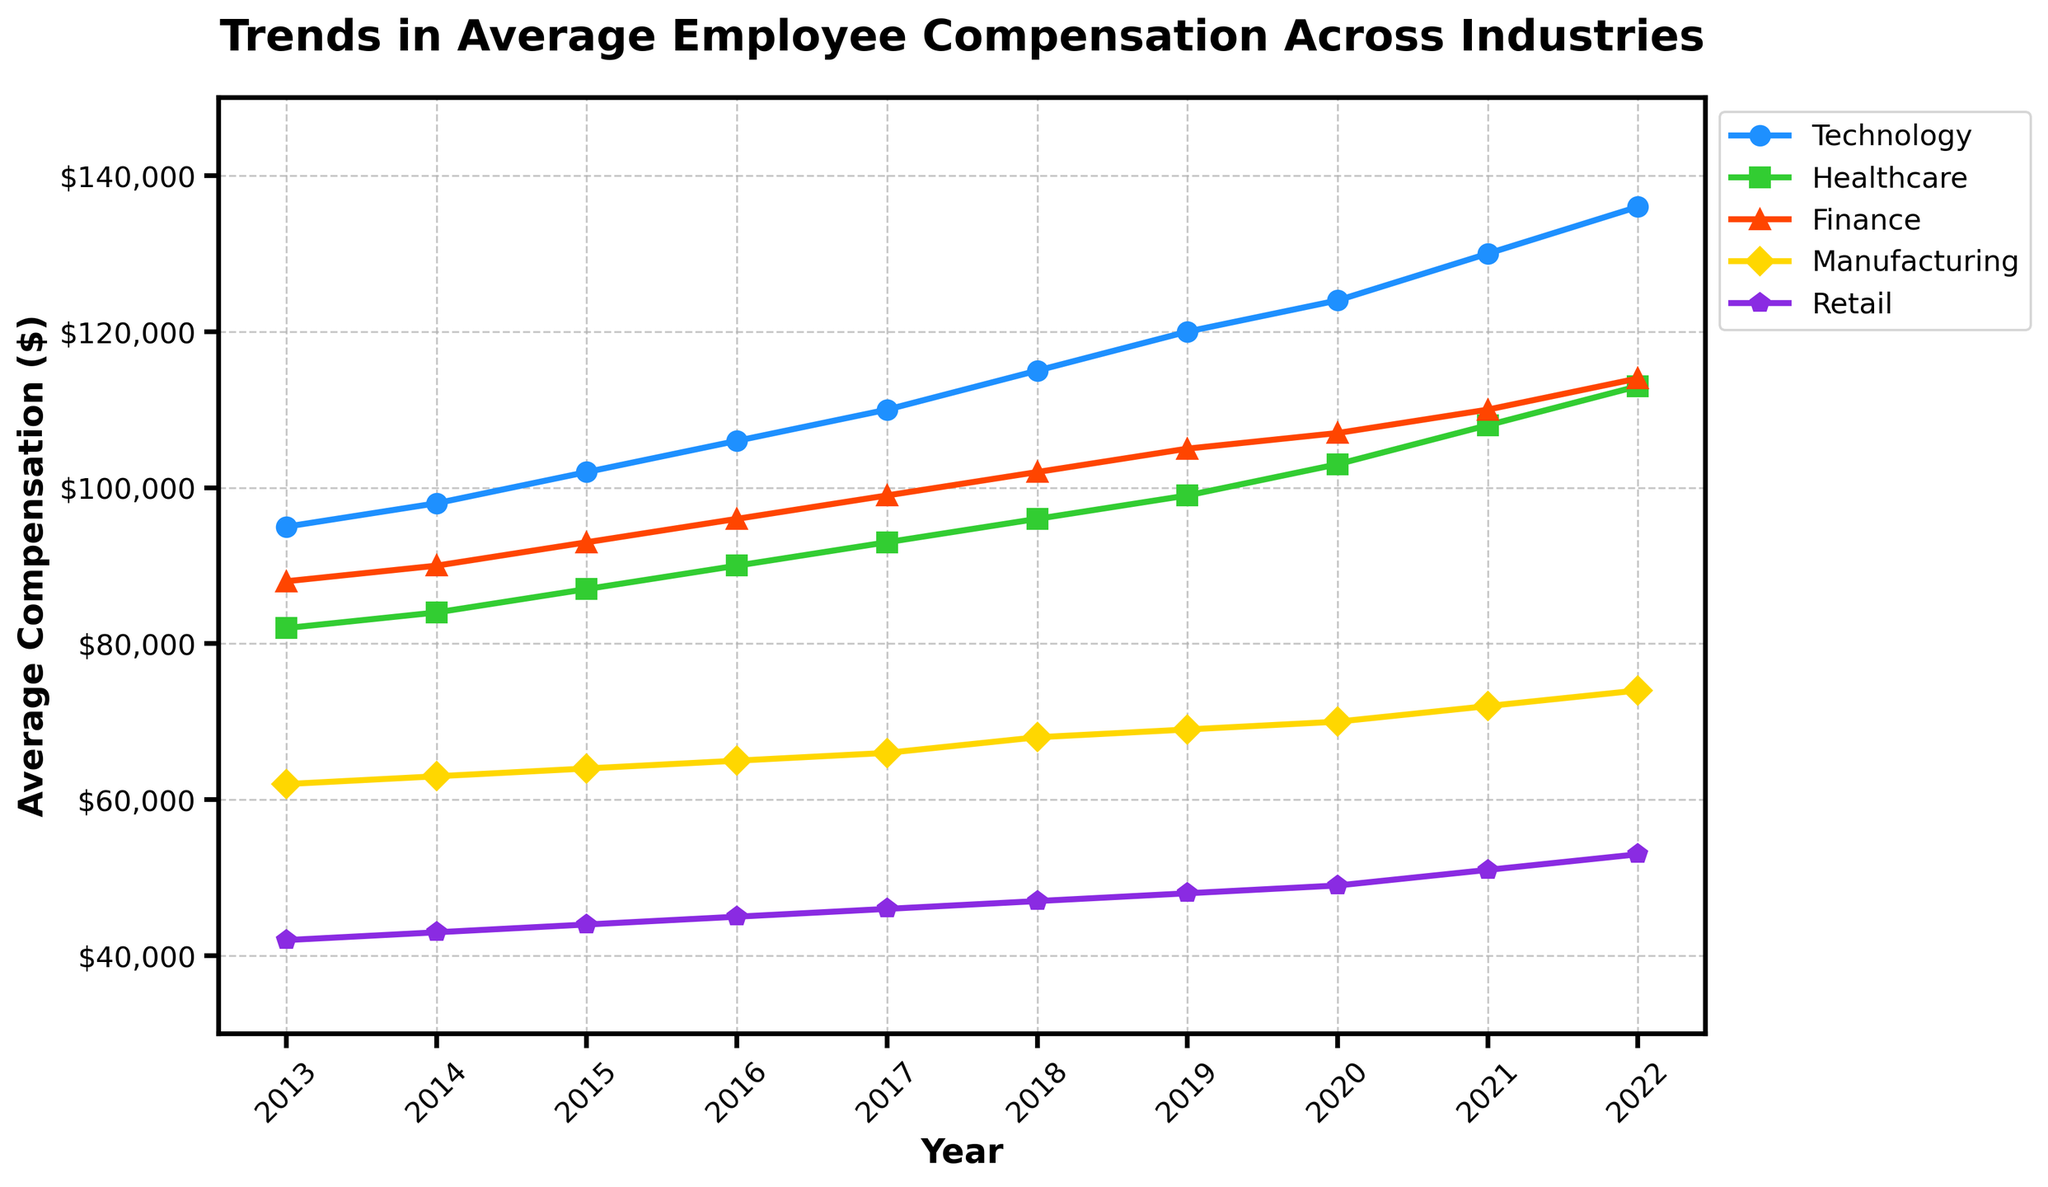What was the average compensation in the Healthcare industry in 2015? Look at the Healthcare industry's data point for the year 2015 on the line chart, find the value associated with it.
Answer: 87,000 Which industry had the highest average compensation in 2022? On the graph, find the line that is the highest in 2022, which corresponds to the highest average compensation that year.
Answer: Technology What was the increase in average compensation for the Finance industry from 2013 to 2020? Find the data points for the Finance industry in 2013 and 2020 on the chart. Subtract the 2013 value from the 2020 value.
Answer: 107,000 - 88,000 = 19,000 Which industry had the smallest growth in average compensation from 2013 to 2022? Calculate the difference in average compensation between 2013 and 2022 for each industry and compare them to find the smallest growth.
Answer: Retail How does the trend in average compensation over the decade for the Manufacturing industry compare to the Technology industry? Compare the slopes of the lines for the Manufacturing and Technology industries. The Technology line has a steeper slope, indicating faster growth.
Answer: Technology increased faster than Manufacturing In which year did the Retail industry's average compensation first exceed $50,000? Locate the Retail industry's line and see when it crosses the $50,000 mark on the y-axis.
Answer: 2021 What is the average yearly increase in compensation in the Technology industry from 2013 to 2022? Subtract the 2013 value from the 2022 value for the Technology industry, then divide by the number of years (2022-2013).
Answer: (136,000 - 95,000) / 9 = 4,555.56 Which two industries had the closest average compensations in 2017? Identify and compare the data points for each industry in the year 2017; find the two industries with the smallest difference.
Answer: Healthcare and Finance How did the 2022 average compensation in the Healthcare industry compare to the 2021 average compensation in the Technology industry? Find the 2022 value for Healthcare and the 2021 value for Technology and compare them.
Answer: 113,000 is less than 130,000 What is the average compensation in the Manufacturing industry exactly between 2018 and 2020? Find the average of the data points for Manufacturing in 2018, 2019, and 2020.
Answer: (68,000 + 69,000 + 70,000) / 3 = 69,000 